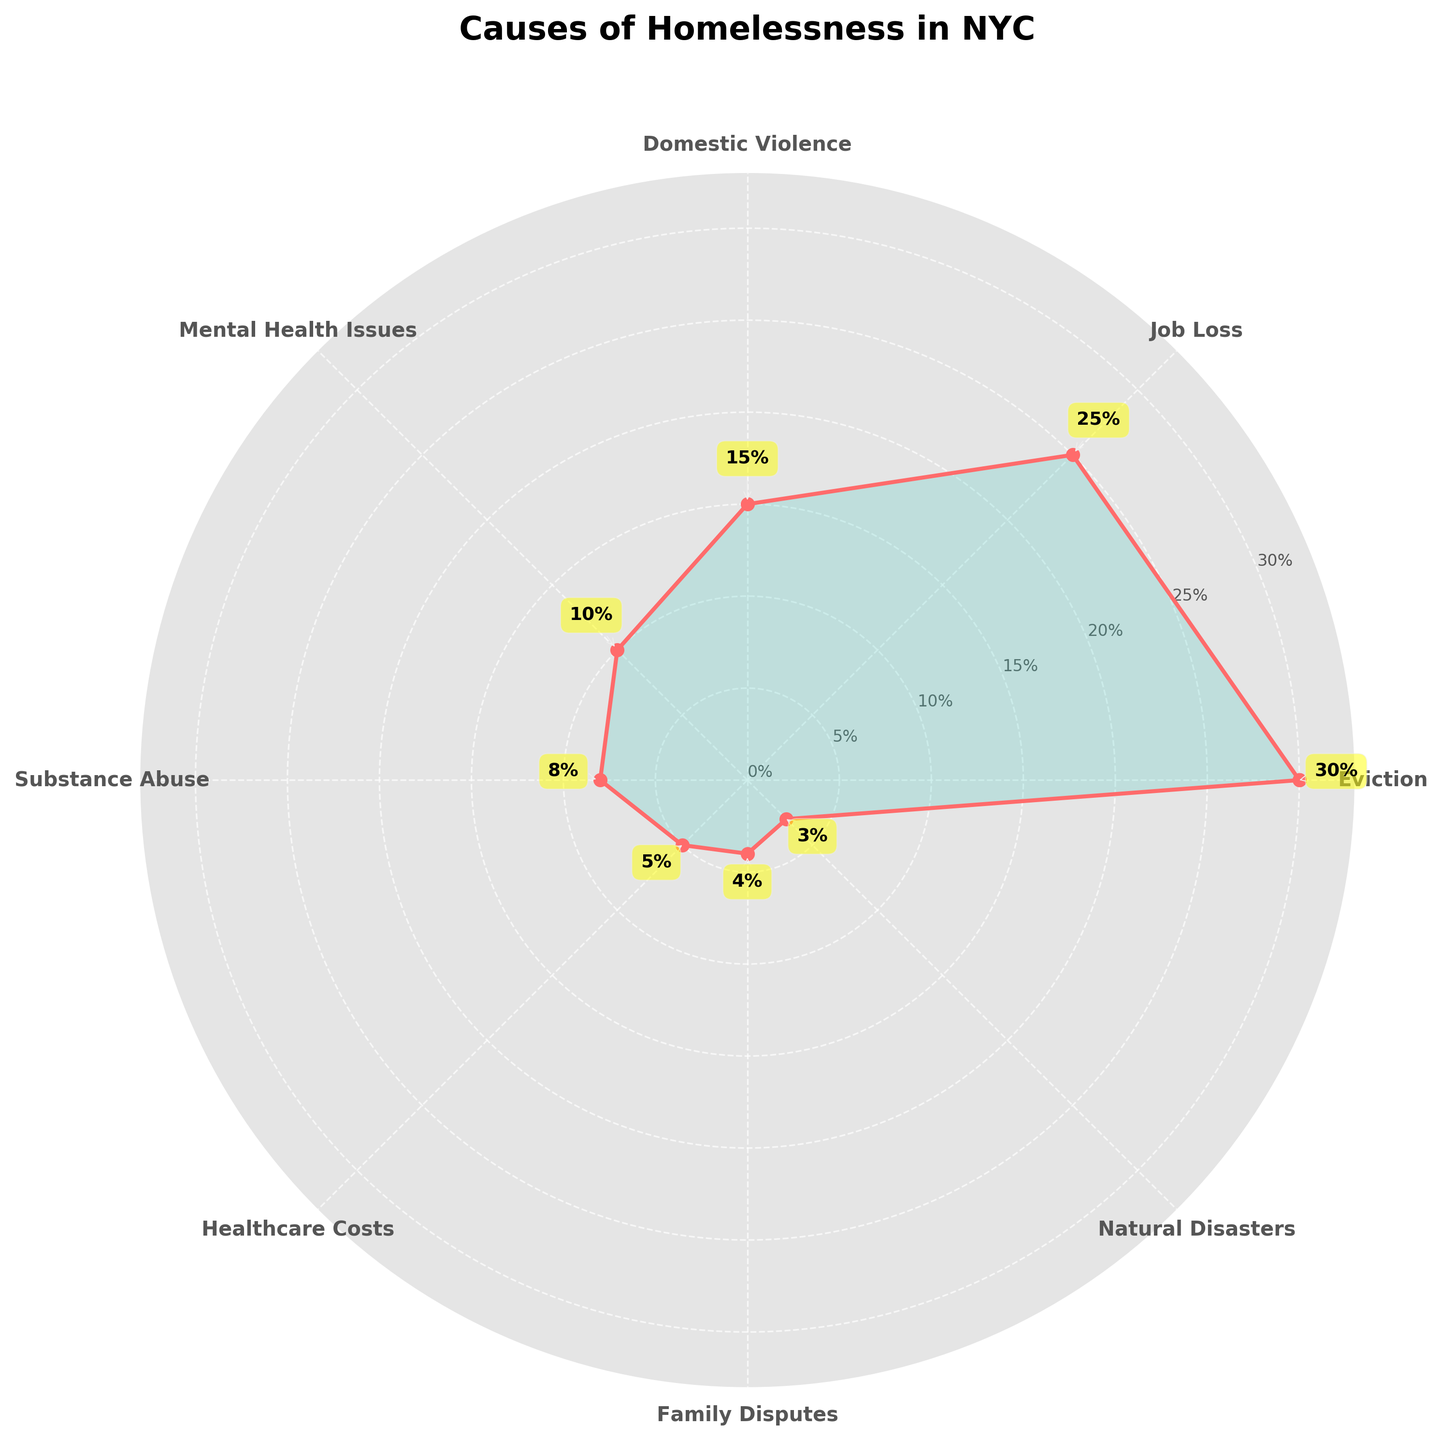what is the title of the polar chart? The title of the polar chart is typically found at the top of the chart and often provides a brief overview of what the chart is about. In this case, the title should summarize the causes of homelessness in NYC.
Answer: Causes of Homelessness in NYC Which cause has the highest proportion in the chart? By looking at the radial distance of each data point from the center, we can determine which one extends furthest. The longest radial value indicates the highest proportion.
Answer: Eviction What is the proportion of Domestic Violence as a cause of homelessness? Find the label "Domestic Violence" on the angular axis and then look at the length of its corresponding radial line. The annotated proportion near the marker will give the answer.
Answer: 15% How many different causes of homelessness are displayed in the chart? Count the number of unique labels around the perimeter of the polar chart to identify the distinct causes.
Answer: 8 What is the combined proportion of Job Loss and Mental Health Issues? Identify the proportions for Job Loss (25%) and Mental Health Issues (10%). Add these values together to find their combined proportion.
Answer: 35% Which of the causes has a lower proportion, Substance Abuse or Healthcare Costs? Compare the radial lengths and annotated percentages for Substance Abuse (8%) and Healthcare Costs (5%). The shorter length represents the lower proportion.
Answer: Healthcare Costs What is the average proportion of Family Disputes, Natural Disasters, and Healthcare Costs? Identify the proportions: Family Disputes (4%), Natural Disasters (3%), Healthcare Costs (5%). Sum these values and divide by the number of causes (3) to find the average.
Answer: 4% In which quadrant of the chart is the label "Job Loss" placed? Examine the polar chart, dividing it mentally into four quadrants based on standard coordinate systems, and locate where "Job Loss" falls within those four sections.
Answer: First Quadrant Which cause has a proportion closest to the overall average of all causes displayed? Calculate the average proportion by summing all proportions (100%) and dividing by the number of causes (8). Compare this average to each individual proportion to determine which is closest.
Answer: Mental Health Issues 